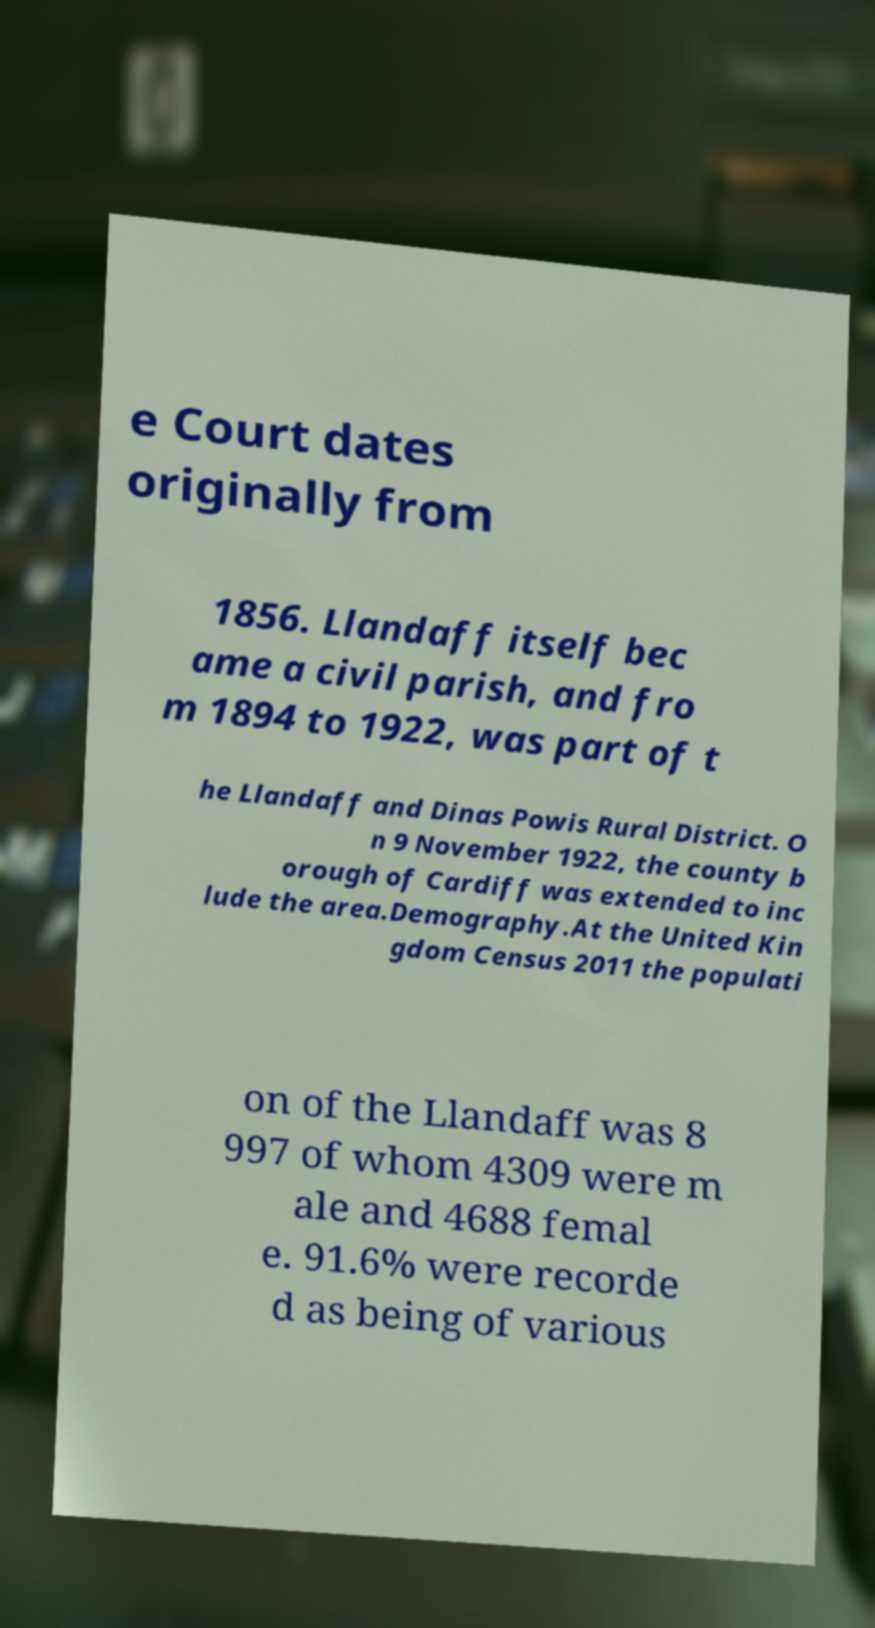Can you read and provide the text displayed in the image?This photo seems to have some interesting text. Can you extract and type it out for me? e Court dates originally from 1856. Llandaff itself bec ame a civil parish, and fro m 1894 to 1922, was part of t he Llandaff and Dinas Powis Rural District. O n 9 November 1922, the county b orough of Cardiff was extended to inc lude the area.Demography.At the United Kin gdom Census 2011 the populati on of the Llandaff was 8 997 of whom 4309 were m ale and 4688 femal e. 91.6% were recorde d as being of various 